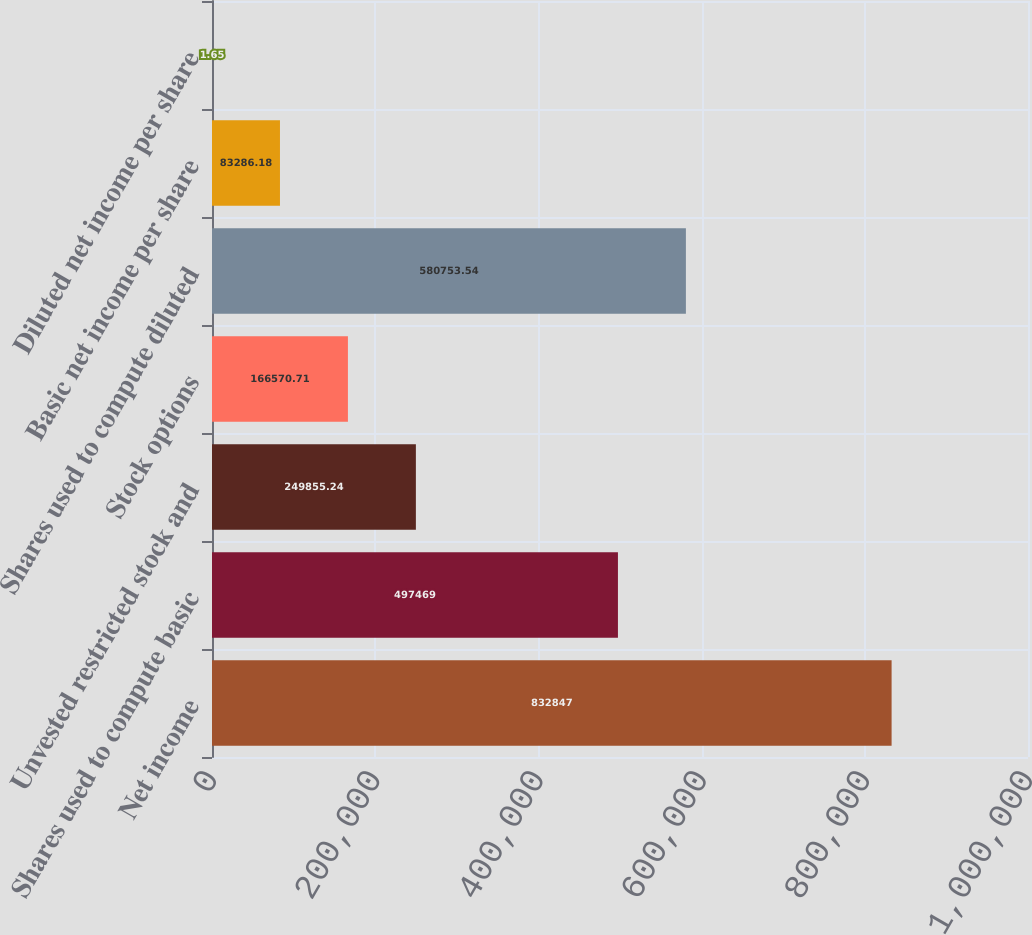<chart> <loc_0><loc_0><loc_500><loc_500><bar_chart><fcel>Net income<fcel>Shares used to compute basic<fcel>Unvested restricted stock and<fcel>Stock options<fcel>Shares used to compute diluted<fcel>Basic net income per share<fcel>Diluted net income per share<nl><fcel>832847<fcel>497469<fcel>249855<fcel>166571<fcel>580754<fcel>83286.2<fcel>1.65<nl></chart> 